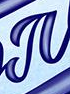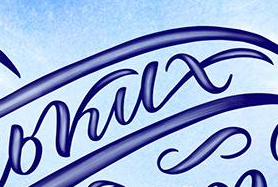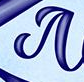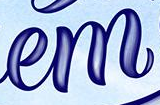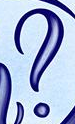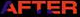Read the text content from these images in order, separated by a semicolon. #; bkux; #; em; ?; AFTER 